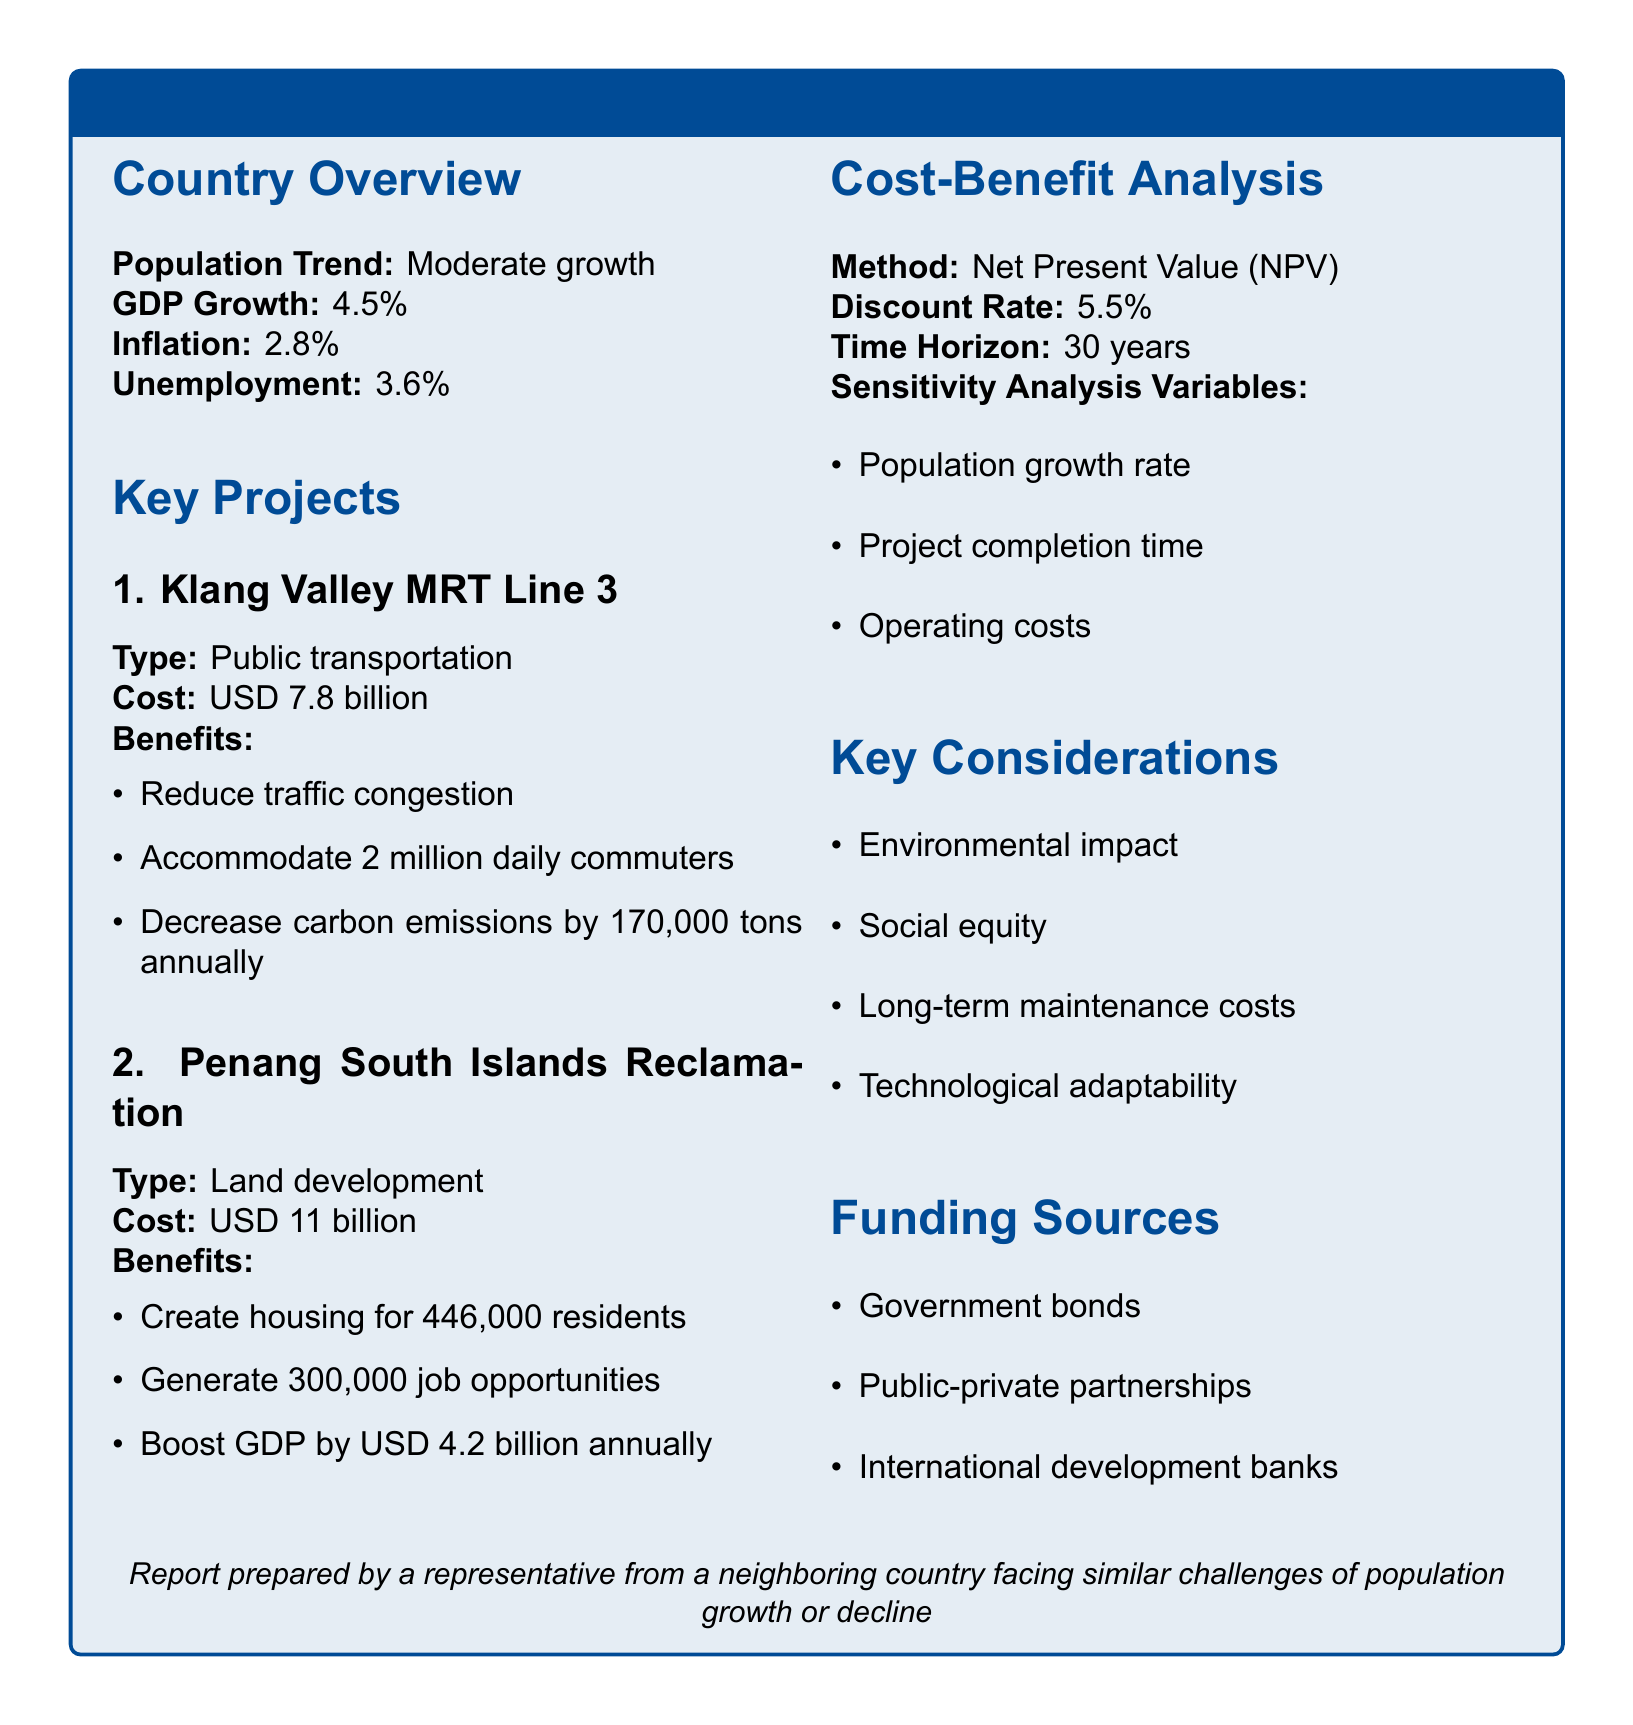what is the estimated cost of Klang Valley MRT Line 3? The estimated cost is directly mentioned in the document under the Klang Valley MRT Line 3 section.
Answer: USD 7.8 billion what are the expected benefits of the Penang South Islands Reclamation? The expected benefits are listed in the Penang South Islands Reclamation section of the report.
Answer: Create housing for 446,000 residents, generate 300,000 job opportunities, boost GDP by USD 4.2 billion annually what is the discount rate used in the cost-benefit analysis? The discount rate is specified under the Cost-Benefit Analysis section of the document.
Answer: 5.5% what time horizon is considered for the projects? The time horizon is mentioned in the Cost-Benefit Analysis section, which outlines the period over which the projects will be analyzed.
Answer: 30 years how many daily commuters will the Klang Valley MRT Line 3 accommodate? This number is mentioned as a benefit in the Klang Valley MRT Line 3 section.
Answer: 2 million which funding sources are listed for the infrastructure projects? The funding sources are outlined in the Funding Sources section and detail how the projects will be financed.
Answer: Government bonds, public-private partnerships, international development banks what is the unemployment rate mentioned in the report? The unemployment rate is included in the Country Overview section as one of the economic indicators.
Answer: 3.6% which factors are considered in the sensitivity analysis? The factors are listed in the Cost-Benefit Analysis section under sensitivity analysis variables.
Answer: Population growth rate, project completion time, operating costs what is the GDP growth rate for Malaysia? The GDP growth rate is a key economic indicator mentioned in the Country Overview section.
Answer: 4.5% 